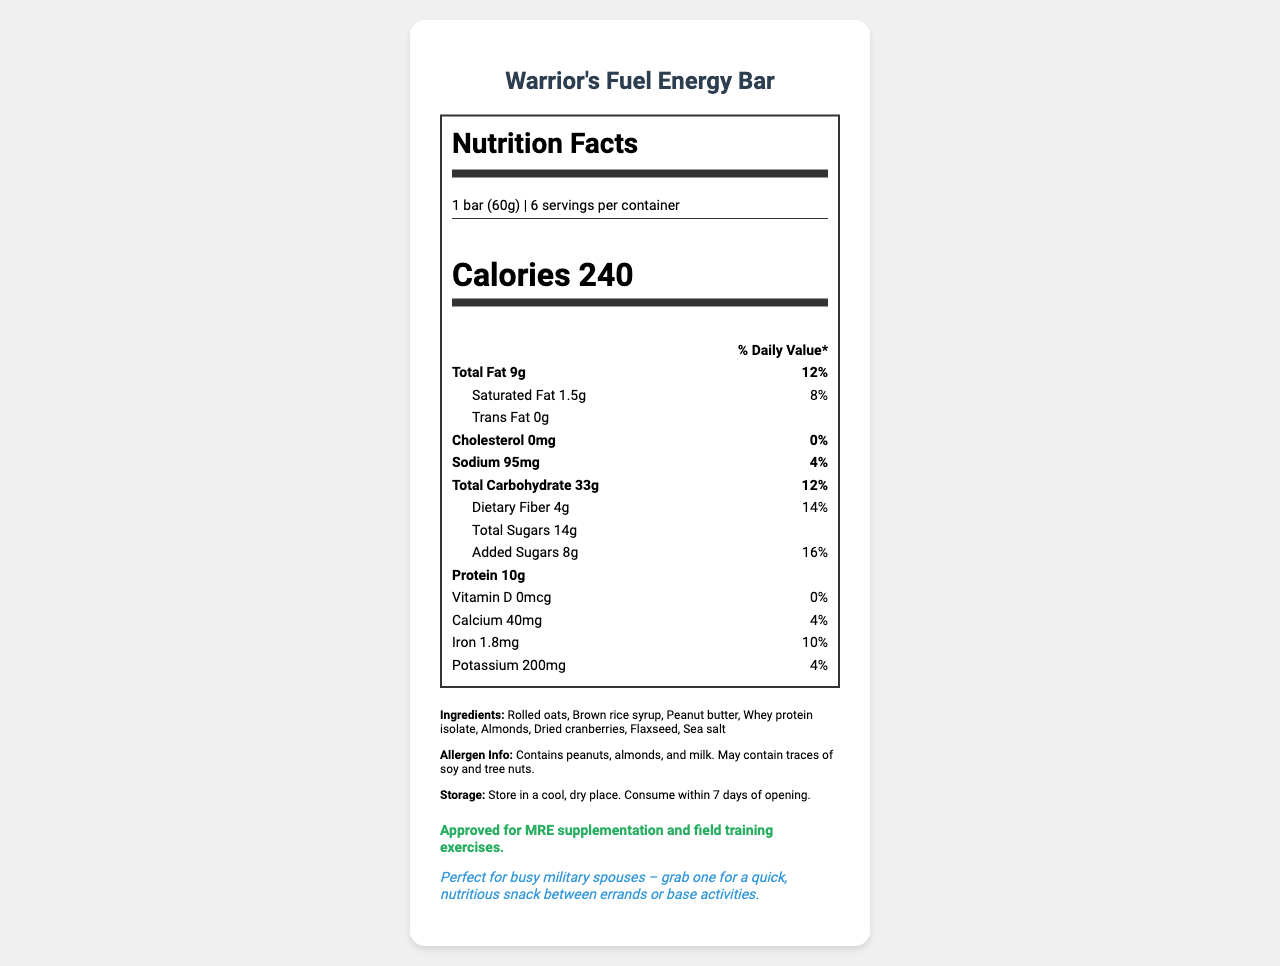How many servings are there per container of the Warrior's Fuel Energy Bar? The document states that there are 6 servings per container.
Answer: 6 What is the serving size of the Warrior's Fuel Energy Bar? The serving size is specified as 1 bar (60g).
Answer: 1 bar (60g) How many calories does one serving of the Warrior's Fuel Energy Bar contain? The document notes that each serving contains 240 calories.
Answer: 240 What is the total fat content in one serving? The Nutrition Facts label shows that the total fat content per serving is 9g.
Answer: 9g Which allergens are present in the Warrior's Fuel Energy Bar? The allergen information specifies that the product contains peanuts, almonds, and milk.
Answer: Peanuts, almonds, and milk What is the amount of sodium in one serving of the Warrior's Fuel Energy Bar? The document mentions that one serving has 95mg of sodium.
Answer: 95mg Does the Warrior's Fuel Energy Bar contain any trans fat? The Nutrition Facts label indicates 0g of trans fat per serving.
Answer: No What is the percentage of daily value for dietary fiber in one serving? The daily value for dietary fiber per serving is noted to be 14%.
Answer: 14% How much protein does one serving of Warrior's Fuel Energy Bar provide? The document states that there are 10g of protein per serving.
Answer: 10g What is the total carbohydrate content per serving? A. 10g B. 20g C. 33g D. 40g The total carbohydrate content is 33g per serving.
Answer: C. 33g Which ingredient is not part of the Warrior's Fuel Energy Bar? A. Rolled oats B. Brown rice syrup C. Sugar D. Dried cranberries Sugar is not listed among the ingredients, whereas rolled oats, brown rice syrup, and dried cranberries are.
Answer: C. Sugar Is this product suitable for MRE supplementation? The document specifies that it is approved for MRE supplementation and field training exercises.
Answer: Yes Summarize the main information provided in the document. This summary includes all main sections of the document such as nutrient breakdown, ingredients, allergens, and specific information for military use.
Answer: The document is a Nutrition Facts label for the Warrior's Fuel Energy Bar, detailing serving size, servings per container, calorie content, macro and micronutrient amounts, ingredients, allergen info, storage instructions, military-specific information, and a time-saving tip for military spouses. What storage instructions are given for the Warrior's Fuel Energy Bar? The document advises to store the bar in a cool, dry place and to consume it within 7 days of opening.
Answer: Store in a cool, dry place. Consume within 7 days of opening. What is the daily value percentage of added sugars in one serving? The daily value percentage for added sugars is listed as 16%.
Answer: 16% How much iron is in one serving of the energy bar? One serving contains 1.8mg of iron.
Answer: 1.8mg Does the Warrior's Fuel Energy Bar contain vitamin D? The document records 0mcg of vitamin D, which amounts to 0% daily value.
Answer: No What are the main ingredients of the Warrior's Fuel Energy Bar? The list of ingredients is clearly provided in the document.
Answer: Rolled oats, Brown rice syrup, Peanut butter, Whey protein isolate, Almonds, Dried cranberries, Flaxseed, Sea salt Can you tell if this energy bar has any preservatives from the information provided? The document does not specify whether the energy bar contains any preservatives.
Answer: Not enough information What makes this product suitable for busy military spouses? The time-saving tip explicitly states that the Warrior's Fuel Energy Bar is ideal for quick, nutritious snacking between errands or base activities.
Answer: Perfect for busy military spouses – grab one for a quick, nutritious snack between errands or base activities. 